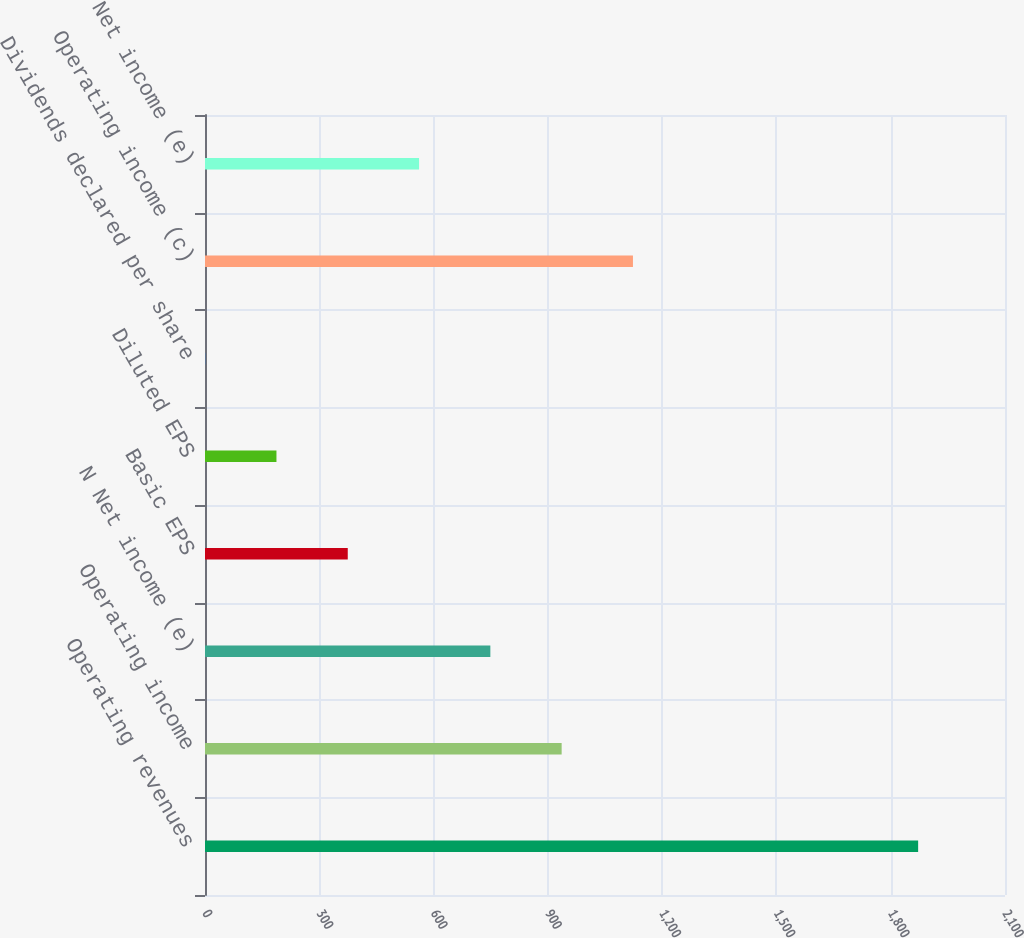<chart> <loc_0><loc_0><loc_500><loc_500><bar_chart><fcel>Operating revenues<fcel>Operating income<fcel>N Net income (e)<fcel>Basic EPS<fcel>Diluted EPS<fcel>Dividends declared per share<fcel>Operating income (c)<fcel>Net income (e)<nl><fcel>1872<fcel>936.21<fcel>749.05<fcel>374.73<fcel>187.57<fcel>0.41<fcel>1123.37<fcel>561.89<nl></chart> 